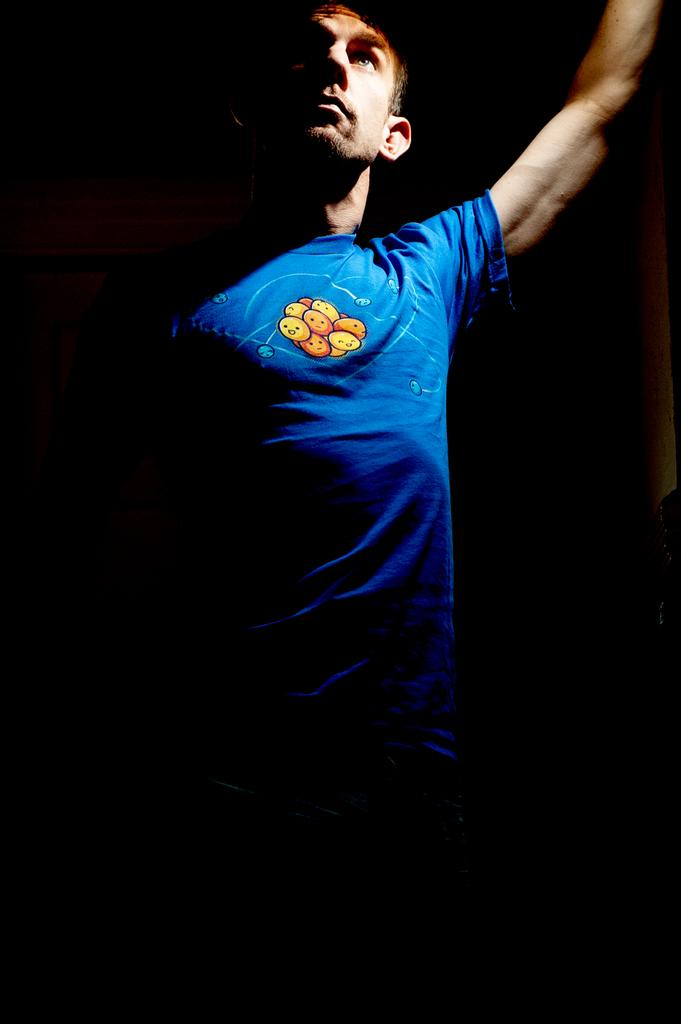Who is the main subject in the image? There is a man in the image. What is the man wearing in the image? The man is wearing a blue T-shirt. What can be observed about the background of the image? The background of the image is dark. How does the man's grandmother react to the fight in the image? There is no mention of a grandmother or a fight in the image, so it is not possible to answer this question. 